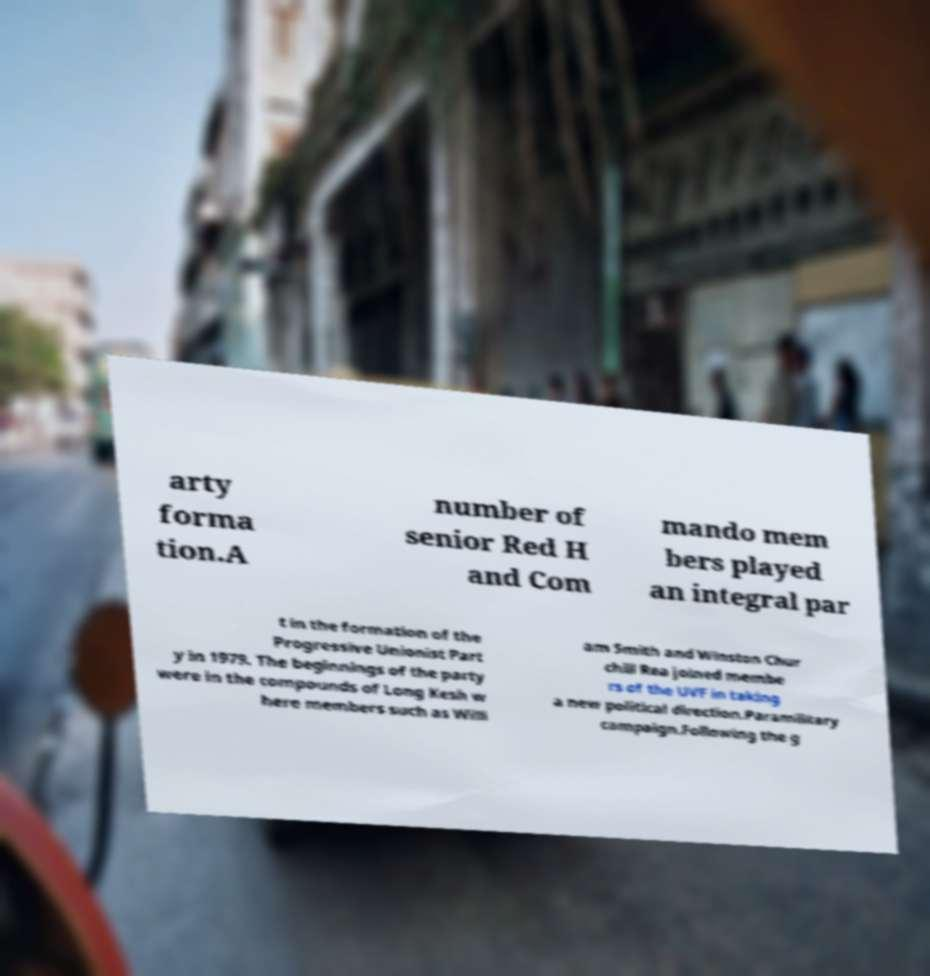What messages or text are displayed in this image? I need them in a readable, typed format. arty forma tion.A number of senior Red H and Com mando mem bers played an integral par t in the formation of the Progressive Unionist Part y in 1979. The beginnings of the party were in the compounds of Long Kesh w here members such as Willi am Smith and Winston Chur chill Rea joined membe rs of the UVF in taking a new political direction.Paramilitary campaign.Following the g 